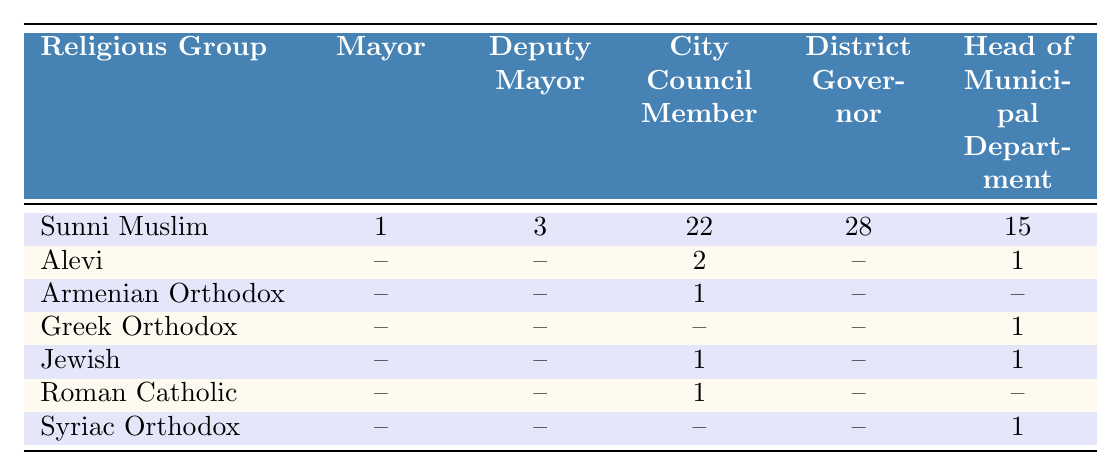What is the total number of Sunni Muslims in municipal government positions? To find the total for Sunni Muslims, we add the values: Mayor (1) + Deputy Mayor (3) + City Council Members (22) + District Governors (28) + Heads of Municipal Department (15) = 69
Answer: 69 How many positions do Alevi hold in the municipal government? Alevi hold 2 City Council Member positions and 1 Head of Municipal Department position, totaling 2 + 1 = 3
Answer: 3 Is there a Roman Catholic in the Mayor position? The table shows that there are no entries for Roman Catholic in the Mayor column, indicating that there is no Roman Catholic in that position
Answer: No Which religious group has the highest number of Deputy Mayors? Looking at the Deputy Mayor column, Sunni Muslims have 3 Deputy Mayors, which is higher than 0 for all other groups, making them the group with the most
Answer: Sunni Muslim How many total City Council Member positions are held by all groups combined? By summing the City Council Member positions: Sunni Muslim (22) + Alevi (2) + Armenian Orthodox (1) + Jewish (1) + Roman Catholic (1) = 27
Answer: 27 What percentage of the total municipal government positions are held by Sunni Muslims? First, calculate the total positions: 69 (Sunni) + 3 (Alevi) + 1 (Armenian) + 0 (Greek) + 2 (Jewish and Roman) + 1 (Syriac) = 76. Sunni Muslims hold 69 of these, so their percentage is (69/76)*100 = 90.79%
Answer: 90.79% Which religious group holds the fewest total municipal positions? Looking at the data, both Armenian Orthodox and Roman Catholic have only 1 position each. However, Armenian Orthodox only holds a City Council Member position, while Roman Catholic also holds one, making them tied for the fewest positions
Answer: Both Armenian Orthodox and Roman Catholic 